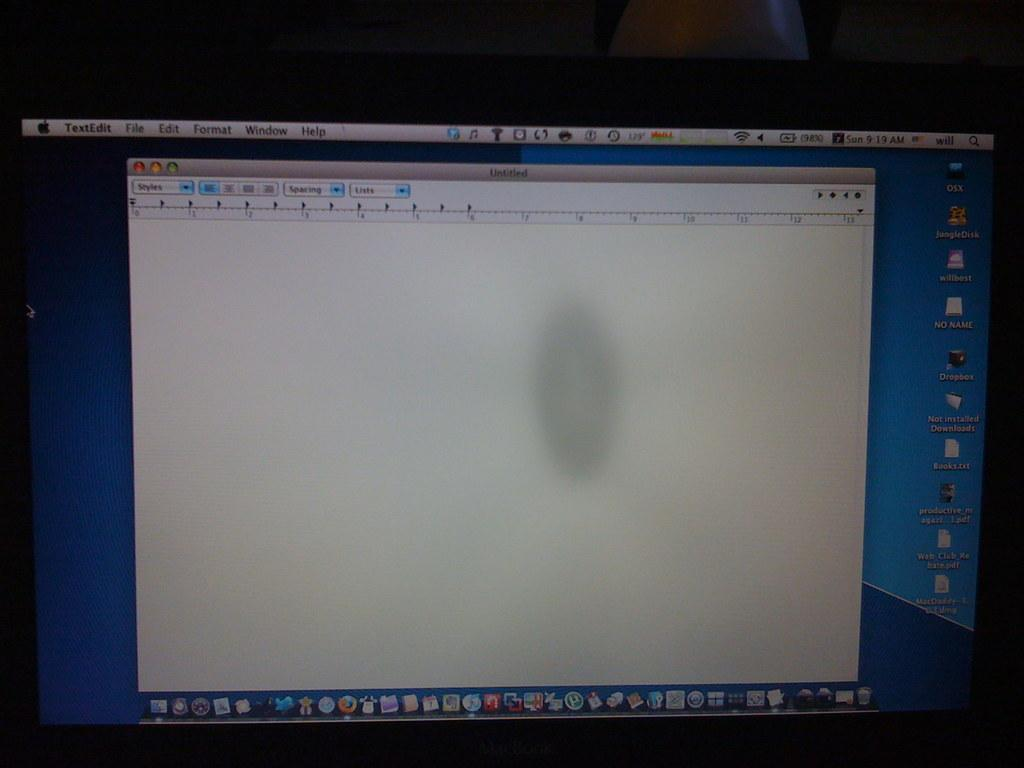<image>
Render a clear and concise summary of the photo. A computer screen sits with a blank document on it in the Textedit program. 